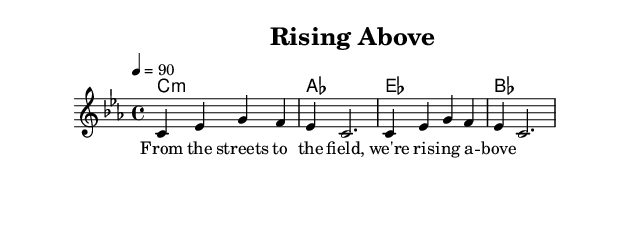What is the key signature of this music? The key signature is C minor, which typically has three flats: B flat, E flat, and A flat. This is identifiable from the indication of the key in the global settings of the sheet music.
Answer: C minor What is the time signature of this music? The time signature is 4/4, which means there are four beats in each measure and the quarter note receives one beat. This is specified in the global settings section of the music sheet.
Answer: 4/4 What is the tempo marking in this music? The tempo marking is 90 beats per minute, which indicates how fast the piece should be played. This is found in the tempo directive within the global settings.
Answer: 90 How many measures are in the melody provided? The melody consists of two measures, as indicated by the separation of the notes and the use of the bar lines. Each complete line of melody notation typically represents one measure.
Answer: 2 What type of music is "Rising Above"? The title "Rising Above" along with the lyrical content suggests it is conscious rap addressing social issues. This can be inferred from the title and the coaching themes implied in the lyrics.
Answer: Conscious rap What chords are played in this piece? The chords listed under the harmonies are C minor, A flat, E flat, and B flat, providing harmonic support for the melody. These chords are indicated in the chord names section of the score.
Answer: C minor, A flat, E flat, B flat What message do the lyrics convey? The lyrics "From the streets to the field, we're rising above" imply themes of overcoming adversity and striving for success, focusing on social issues affecting urban youth. This can be interpreted from the content of the lyrics provided.
Answer: Overcoming adversity 